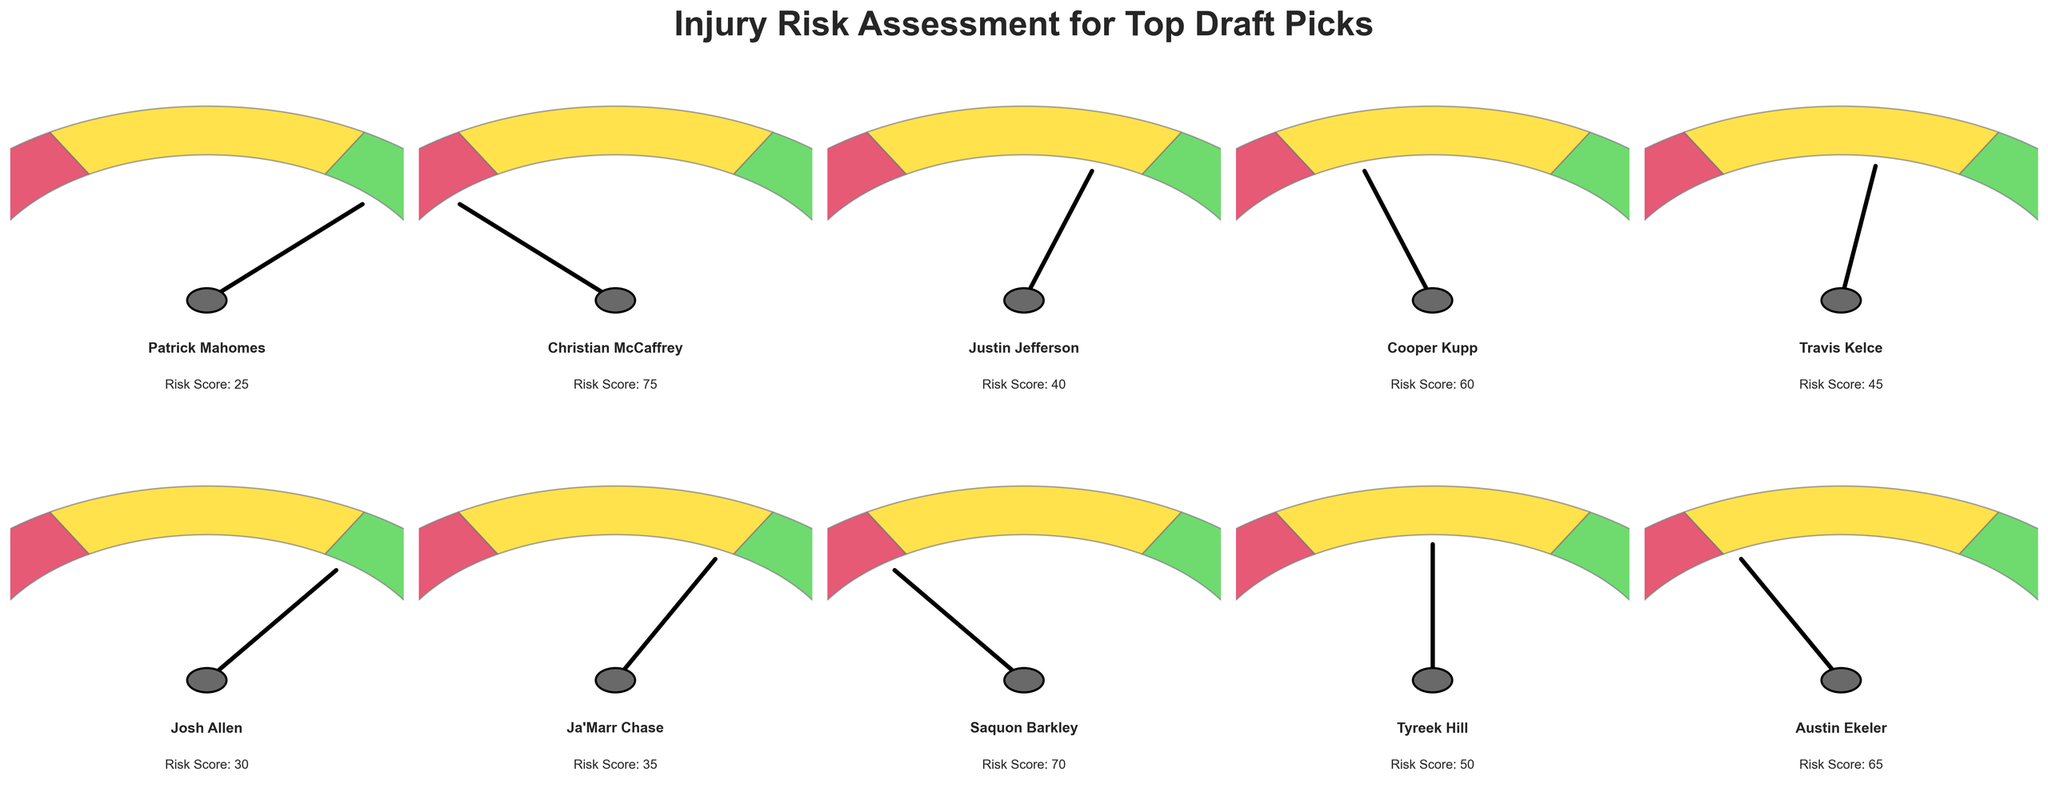what is the title of the figure? The title of the figure is always located at the top. From the given data and code, the title should be "Injury Risk Assessment for Top Draft Picks"
Answer: Injury Risk Assessment for Top Draft Picks Which player has the highest injury risk score? To find the player with the highest injury risk score, look for the gauge with the highest needle position. Christian McCaffrey has the highest score of 75.
Answer: Christian McCaffrey How many players have an injury risk score above 50? Count the number of players with a needle position indicating a score above 50. There are 5 players: Christian McCaffrey, Cooper Kupp, Saquon Barkley, Tyreek Hill, and Austin Ekeler.
Answer: 5 Which player has the lowest injury risk score? The player with the lowest injury risk score is the one with the needle closest to 0. Patrick Mahomes has the lowest score of 25.
Answer: Patrick Mahomes What is the average injury risk score of all players? Add up all the injury risk scores and divide by the number of players. (25 + 75 + 40 + 60 + 45 + 30 + 35 + 70 + 50 + 65) / 10 = 49.5
Answer: 49.5 Which player has a risk score closer to 50, Travis Kelce or Tyreek Hill? Compare the injury risk scores of Travis Kelce and Tyreek Hill. Travis Kelce has a score of 45, which is closer to 50 than Tyreek Hill's score of 50.
Answer: Tyreek Hill In which color range does Josh Allen's injury risk score fall? Identify the color ranges defined in the gauge chart and see where Josh Allen's score of 30 falls. This score falls within the "limegreen" (0-60) range.
Answer: limegreen How many players fall in the 'crimson' risk zone (above 120 degrees)? Look for players with scores that position the needle in the 'crimson' zone. There are no players with scores high enough to be in the 'crimson' zone (above 120 degrees which corresponds to scores of 67 or greater).
Answer: 0 Which player's risk score is closest to the average score? Compare each player's score to the calculated average of 49.5 and identify the closest. Tyreek Hill, with a score of 50, is closest.
Answer: Tyreek Hill 